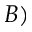Convert formula to latex. <formula><loc_0><loc_0><loc_500><loc_500>B )</formula> 